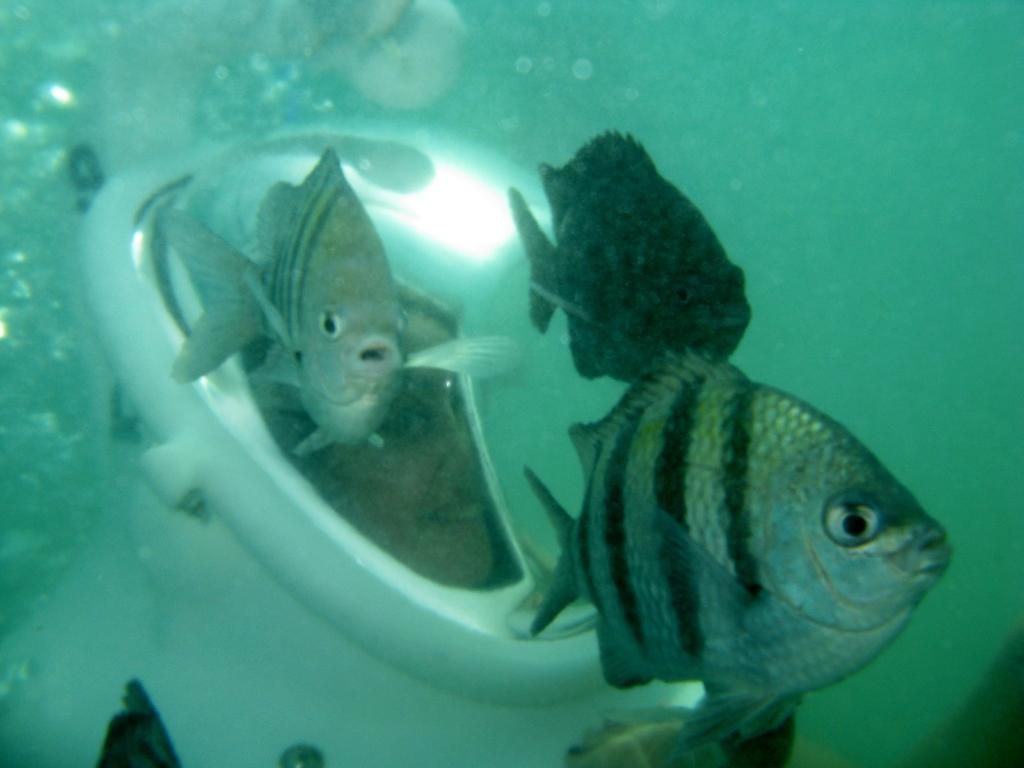What is happening in the water in the image? There are fishes moving in the water. Can you describe the person's face in the image? Unfortunately, the provided facts do not mention any details about the person's face. What might the person be doing in relation to the fishes? Based on the facts, we cannot determine what the person might be doing in relation to the fishes. What type of flock is flying over the person's head in the image? There is no flock visible in the image; only fishes moving in the water are mentioned. 